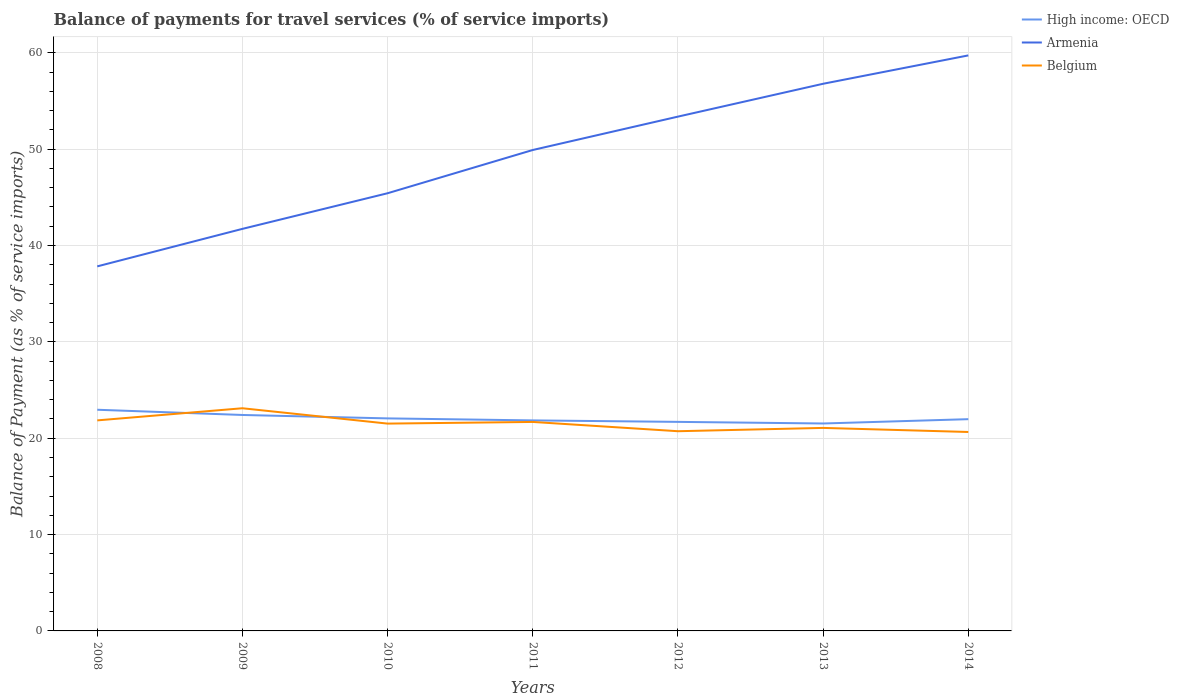Across all years, what is the maximum balance of payments for travel services in Belgium?
Make the answer very short. 20.65. In which year was the balance of payments for travel services in Belgium maximum?
Provide a short and direct response. 2014. What is the total balance of payments for travel services in High income: OECD in the graph?
Keep it short and to the point. 0.15. What is the difference between the highest and the second highest balance of payments for travel services in Belgium?
Give a very brief answer. 2.46. How many lines are there?
Your answer should be very brief. 3. What is the difference between two consecutive major ticks on the Y-axis?
Provide a succinct answer. 10. Does the graph contain any zero values?
Your answer should be very brief. No. Does the graph contain grids?
Keep it short and to the point. Yes. How are the legend labels stacked?
Give a very brief answer. Vertical. What is the title of the graph?
Give a very brief answer. Balance of payments for travel services (% of service imports). What is the label or title of the X-axis?
Offer a very short reply. Years. What is the label or title of the Y-axis?
Ensure brevity in your answer.  Balance of Payment (as % of service imports). What is the Balance of Payment (as % of service imports) of High income: OECD in 2008?
Your response must be concise. 22.96. What is the Balance of Payment (as % of service imports) in Armenia in 2008?
Your answer should be very brief. 37.84. What is the Balance of Payment (as % of service imports) in Belgium in 2008?
Your answer should be compact. 21.85. What is the Balance of Payment (as % of service imports) of High income: OECD in 2009?
Make the answer very short. 22.41. What is the Balance of Payment (as % of service imports) of Armenia in 2009?
Ensure brevity in your answer.  41.73. What is the Balance of Payment (as % of service imports) of Belgium in 2009?
Offer a terse response. 23.11. What is the Balance of Payment (as % of service imports) of High income: OECD in 2010?
Provide a succinct answer. 22.06. What is the Balance of Payment (as % of service imports) of Armenia in 2010?
Keep it short and to the point. 45.43. What is the Balance of Payment (as % of service imports) in Belgium in 2010?
Provide a short and direct response. 21.52. What is the Balance of Payment (as % of service imports) in High income: OECD in 2011?
Make the answer very short. 21.85. What is the Balance of Payment (as % of service imports) of Armenia in 2011?
Offer a very short reply. 49.91. What is the Balance of Payment (as % of service imports) of Belgium in 2011?
Give a very brief answer. 21.69. What is the Balance of Payment (as % of service imports) of High income: OECD in 2012?
Make the answer very short. 21.7. What is the Balance of Payment (as % of service imports) in Armenia in 2012?
Your response must be concise. 53.38. What is the Balance of Payment (as % of service imports) of Belgium in 2012?
Offer a terse response. 20.73. What is the Balance of Payment (as % of service imports) of High income: OECD in 2013?
Offer a very short reply. 21.53. What is the Balance of Payment (as % of service imports) in Armenia in 2013?
Ensure brevity in your answer.  56.79. What is the Balance of Payment (as % of service imports) in Belgium in 2013?
Offer a terse response. 21.07. What is the Balance of Payment (as % of service imports) in High income: OECD in 2014?
Your answer should be very brief. 21.98. What is the Balance of Payment (as % of service imports) of Armenia in 2014?
Provide a succinct answer. 59.73. What is the Balance of Payment (as % of service imports) of Belgium in 2014?
Provide a succinct answer. 20.65. Across all years, what is the maximum Balance of Payment (as % of service imports) of High income: OECD?
Ensure brevity in your answer.  22.96. Across all years, what is the maximum Balance of Payment (as % of service imports) of Armenia?
Provide a short and direct response. 59.73. Across all years, what is the maximum Balance of Payment (as % of service imports) in Belgium?
Keep it short and to the point. 23.11. Across all years, what is the minimum Balance of Payment (as % of service imports) of High income: OECD?
Ensure brevity in your answer.  21.53. Across all years, what is the minimum Balance of Payment (as % of service imports) of Armenia?
Offer a terse response. 37.84. Across all years, what is the minimum Balance of Payment (as % of service imports) of Belgium?
Make the answer very short. 20.65. What is the total Balance of Payment (as % of service imports) in High income: OECD in the graph?
Ensure brevity in your answer.  154.48. What is the total Balance of Payment (as % of service imports) in Armenia in the graph?
Your answer should be compact. 344.81. What is the total Balance of Payment (as % of service imports) in Belgium in the graph?
Give a very brief answer. 150.62. What is the difference between the Balance of Payment (as % of service imports) of High income: OECD in 2008 and that in 2009?
Give a very brief answer. 0.54. What is the difference between the Balance of Payment (as % of service imports) of Armenia in 2008 and that in 2009?
Make the answer very short. -3.89. What is the difference between the Balance of Payment (as % of service imports) of Belgium in 2008 and that in 2009?
Your response must be concise. -1.26. What is the difference between the Balance of Payment (as % of service imports) of High income: OECD in 2008 and that in 2010?
Your response must be concise. 0.9. What is the difference between the Balance of Payment (as % of service imports) in Armenia in 2008 and that in 2010?
Provide a short and direct response. -7.59. What is the difference between the Balance of Payment (as % of service imports) of Belgium in 2008 and that in 2010?
Offer a terse response. 0.33. What is the difference between the Balance of Payment (as % of service imports) of High income: OECD in 2008 and that in 2011?
Your response must be concise. 1.11. What is the difference between the Balance of Payment (as % of service imports) in Armenia in 2008 and that in 2011?
Offer a terse response. -12.08. What is the difference between the Balance of Payment (as % of service imports) in Belgium in 2008 and that in 2011?
Offer a terse response. 0.16. What is the difference between the Balance of Payment (as % of service imports) of High income: OECD in 2008 and that in 2012?
Your answer should be very brief. 1.26. What is the difference between the Balance of Payment (as % of service imports) of Armenia in 2008 and that in 2012?
Your answer should be compact. -15.54. What is the difference between the Balance of Payment (as % of service imports) in Belgium in 2008 and that in 2012?
Offer a very short reply. 1.12. What is the difference between the Balance of Payment (as % of service imports) of High income: OECD in 2008 and that in 2013?
Ensure brevity in your answer.  1.43. What is the difference between the Balance of Payment (as % of service imports) of Armenia in 2008 and that in 2013?
Keep it short and to the point. -18.95. What is the difference between the Balance of Payment (as % of service imports) in Belgium in 2008 and that in 2013?
Provide a short and direct response. 0.78. What is the difference between the Balance of Payment (as % of service imports) of High income: OECD in 2008 and that in 2014?
Provide a succinct answer. 0.98. What is the difference between the Balance of Payment (as % of service imports) in Armenia in 2008 and that in 2014?
Keep it short and to the point. -21.9. What is the difference between the Balance of Payment (as % of service imports) of Belgium in 2008 and that in 2014?
Your response must be concise. 1.2. What is the difference between the Balance of Payment (as % of service imports) in High income: OECD in 2009 and that in 2010?
Make the answer very short. 0.36. What is the difference between the Balance of Payment (as % of service imports) in Armenia in 2009 and that in 2010?
Your response must be concise. -3.7. What is the difference between the Balance of Payment (as % of service imports) in Belgium in 2009 and that in 2010?
Your answer should be very brief. 1.59. What is the difference between the Balance of Payment (as % of service imports) in High income: OECD in 2009 and that in 2011?
Give a very brief answer. 0.56. What is the difference between the Balance of Payment (as % of service imports) of Armenia in 2009 and that in 2011?
Keep it short and to the point. -8.19. What is the difference between the Balance of Payment (as % of service imports) of Belgium in 2009 and that in 2011?
Keep it short and to the point. 1.42. What is the difference between the Balance of Payment (as % of service imports) of High income: OECD in 2009 and that in 2012?
Offer a terse response. 0.72. What is the difference between the Balance of Payment (as % of service imports) in Armenia in 2009 and that in 2012?
Your response must be concise. -11.65. What is the difference between the Balance of Payment (as % of service imports) of Belgium in 2009 and that in 2012?
Your answer should be very brief. 2.38. What is the difference between the Balance of Payment (as % of service imports) in High income: OECD in 2009 and that in 2013?
Your answer should be very brief. 0.88. What is the difference between the Balance of Payment (as % of service imports) of Armenia in 2009 and that in 2013?
Ensure brevity in your answer.  -15.06. What is the difference between the Balance of Payment (as % of service imports) in Belgium in 2009 and that in 2013?
Ensure brevity in your answer.  2.04. What is the difference between the Balance of Payment (as % of service imports) of High income: OECD in 2009 and that in 2014?
Your answer should be very brief. 0.44. What is the difference between the Balance of Payment (as % of service imports) in Armenia in 2009 and that in 2014?
Give a very brief answer. -18. What is the difference between the Balance of Payment (as % of service imports) in Belgium in 2009 and that in 2014?
Keep it short and to the point. 2.46. What is the difference between the Balance of Payment (as % of service imports) in High income: OECD in 2010 and that in 2011?
Your answer should be compact. 0.21. What is the difference between the Balance of Payment (as % of service imports) in Armenia in 2010 and that in 2011?
Your answer should be compact. -4.49. What is the difference between the Balance of Payment (as % of service imports) in Belgium in 2010 and that in 2011?
Your answer should be compact. -0.17. What is the difference between the Balance of Payment (as % of service imports) in High income: OECD in 2010 and that in 2012?
Ensure brevity in your answer.  0.36. What is the difference between the Balance of Payment (as % of service imports) of Armenia in 2010 and that in 2012?
Your response must be concise. -7.95. What is the difference between the Balance of Payment (as % of service imports) in Belgium in 2010 and that in 2012?
Make the answer very short. 0.79. What is the difference between the Balance of Payment (as % of service imports) in High income: OECD in 2010 and that in 2013?
Provide a succinct answer. 0.53. What is the difference between the Balance of Payment (as % of service imports) of Armenia in 2010 and that in 2013?
Keep it short and to the point. -11.36. What is the difference between the Balance of Payment (as % of service imports) of Belgium in 2010 and that in 2013?
Provide a short and direct response. 0.45. What is the difference between the Balance of Payment (as % of service imports) in High income: OECD in 2010 and that in 2014?
Provide a short and direct response. 0.08. What is the difference between the Balance of Payment (as % of service imports) of Armenia in 2010 and that in 2014?
Provide a succinct answer. -14.31. What is the difference between the Balance of Payment (as % of service imports) in Belgium in 2010 and that in 2014?
Provide a short and direct response. 0.87. What is the difference between the Balance of Payment (as % of service imports) of High income: OECD in 2011 and that in 2012?
Give a very brief answer. 0.15. What is the difference between the Balance of Payment (as % of service imports) of Armenia in 2011 and that in 2012?
Make the answer very short. -3.46. What is the difference between the Balance of Payment (as % of service imports) in Belgium in 2011 and that in 2012?
Ensure brevity in your answer.  0.96. What is the difference between the Balance of Payment (as % of service imports) in High income: OECD in 2011 and that in 2013?
Your response must be concise. 0.32. What is the difference between the Balance of Payment (as % of service imports) in Armenia in 2011 and that in 2013?
Your answer should be very brief. -6.87. What is the difference between the Balance of Payment (as % of service imports) of Belgium in 2011 and that in 2013?
Provide a succinct answer. 0.62. What is the difference between the Balance of Payment (as % of service imports) of High income: OECD in 2011 and that in 2014?
Your response must be concise. -0.13. What is the difference between the Balance of Payment (as % of service imports) in Armenia in 2011 and that in 2014?
Your answer should be compact. -9.82. What is the difference between the Balance of Payment (as % of service imports) of Belgium in 2011 and that in 2014?
Give a very brief answer. 1.04. What is the difference between the Balance of Payment (as % of service imports) in High income: OECD in 2012 and that in 2013?
Your answer should be very brief. 0.17. What is the difference between the Balance of Payment (as % of service imports) in Armenia in 2012 and that in 2013?
Provide a succinct answer. -3.41. What is the difference between the Balance of Payment (as % of service imports) in Belgium in 2012 and that in 2013?
Provide a succinct answer. -0.34. What is the difference between the Balance of Payment (as % of service imports) in High income: OECD in 2012 and that in 2014?
Provide a short and direct response. -0.28. What is the difference between the Balance of Payment (as % of service imports) in Armenia in 2012 and that in 2014?
Offer a terse response. -6.35. What is the difference between the Balance of Payment (as % of service imports) of Belgium in 2012 and that in 2014?
Offer a terse response. 0.08. What is the difference between the Balance of Payment (as % of service imports) of High income: OECD in 2013 and that in 2014?
Offer a terse response. -0.45. What is the difference between the Balance of Payment (as % of service imports) in Armenia in 2013 and that in 2014?
Provide a short and direct response. -2.94. What is the difference between the Balance of Payment (as % of service imports) in Belgium in 2013 and that in 2014?
Give a very brief answer. 0.42. What is the difference between the Balance of Payment (as % of service imports) of High income: OECD in 2008 and the Balance of Payment (as % of service imports) of Armenia in 2009?
Keep it short and to the point. -18.77. What is the difference between the Balance of Payment (as % of service imports) in High income: OECD in 2008 and the Balance of Payment (as % of service imports) in Belgium in 2009?
Make the answer very short. -0.15. What is the difference between the Balance of Payment (as % of service imports) of Armenia in 2008 and the Balance of Payment (as % of service imports) of Belgium in 2009?
Provide a short and direct response. 14.73. What is the difference between the Balance of Payment (as % of service imports) of High income: OECD in 2008 and the Balance of Payment (as % of service imports) of Armenia in 2010?
Offer a very short reply. -22.47. What is the difference between the Balance of Payment (as % of service imports) of High income: OECD in 2008 and the Balance of Payment (as % of service imports) of Belgium in 2010?
Your answer should be compact. 1.44. What is the difference between the Balance of Payment (as % of service imports) in Armenia in 2008 and the Balance of Payment (as % of service imports) in Belgium in 2010?
Keep it short and to the point. 16.32. What is the difference between the Balance of Payment (as % of service imports) in High income: OECD in 2008 and the Balance of Payment (as % of service imports) in Armenia in 2011?
Ensure brevity in your answer.  -26.96. What is the difference between the Balance of Payment (as % of service imports) in High income: OECD in 2008 and the Balance of Payment (as % of service imports) in Belgium in 2011?
Provide a short and direct response. 1.26. What is the difference between the Balance of Payment (as % of service imports) in Armenia in 2008 and the Balance of Payment (as % of service imports) in Belgium in 2011?
Your response must be concise. 16.15. What is the difference between the Balance of Payment (as % of service imports) of High income: OECD in 2008 and the Balance of Payment (as % of service imports) of Armenia in 2012?
Provide a succinct answer. -30.42. What is the difference between the Balance of Payment (as % of service imports) in High income: OECD in 2008 and the Balance of Payment (as % of service imports) in Belgium in 2012?
Your answer should be very brief. 2.23. What is the difference between the Balance of Payment (as % of service imports) of Armenia in 2008 and the Balance of Payment (as % of service imports) of Belgium in 2012?
Your response must be concise. 17.11. What is the difference between the Balance of Payment (as % of service imports) in High income: OECD in 2008 and the Balance of Payment (as % of service imports) in Armenia in 2013?
Your answer should be compact. -33.83. What is the difference between the Balance of Payment (as % of service imports) in High income: OECD in 2008 and the Balance of Payment (as % of service imports) in Belgium in 2013?
Your response must be concise. 1.89. What is the difference between the Balance of Payment (as % of service imports) in Armenia in 2008 and the Balance of Payment (as % of service imports) in Belgium in 2013?
Provide a succinct answer. 16.77. What is the difference between the Balance of Payment (as % of service imports) in High income: OECD in 2008 and the Balance of Payment (as % of service imports) in Armenia in 2014?
Your answer should be compact. -36.78. What is the difference between the Balance of Payment (as % of service imports) of High income: OECD in 2008 and the Balance of Payment (as % of service imports) of Belgium in 2014?
Give a very brief answer. 2.31. What is the difference between the Balance of Payment (as % of service imports) in Armenia in 2008 and the Balance of Payment (as % of service imports) in Belgium in 2014?
Offer a very short reply. 17.19. What is the difference between the Balance of Payment (as % of service imports) in High income: OECD in 2009 and the Balance of Payment (as % of service imports) in Armenia in 2010?
Your answer should be very brief. -23.01. What is the difference between the Balance of Payment (as % of service imports) in High income: OECD in 2009 and the Balance of Payment (as % of service imports) in Belgium in 2010?
Your answer should be very brief. 0.9. What is the difference between the Balance of Payment (as % of service imports) in Armenia in 2009 and the Balance of Payment (as % of service imports) in Belgium in 2010?
Ensure brevity in your answer.  20.21. What is the difference between the Balance of Payment (as % of service imports) of High income: OECD in 2009 and the Balance of Payment (as % of service imports) of Armenia in 2011?
Provide a short and direct response. -27.5. What is the difference between the Balance of Payment (as % of service imports) in High income: OECD in 2009 and the Balance of Payment (as % of service imports) in Belgium in 2011?
Give a very brief answer. 0.72. What is the difference between the Balance of Payment (as % of service imports) in Armenia in 2009 and the Balance of Payment (as % of service imports) in Belgium in 2011?
Provide a short and direct response. 20.04. What is the difference between the Balance of Payment (as % of service imports) in High income: OECD in 2009 and the Balance of Payment (as % of service imports) in Armenia in 2012?
Provide a succinct answer. -30.97. What is the difference between the Balance of Payment (as % of service imports) in High income: OECD in 2009 and the Balance of Payment (as % of service imports) in Belgium in 2012?
Your answer should be very brief. 1.69. What is the difference between the Balance of Payment (as % of service imports) of Armenia in 2009 and the Balance of Payment (as % of service imports) of Belgium in 2012?
Provide a short and direct response. 21. What is the difference between the Balance of Payment (as % of service imports) in High income: OECD in 2009 and the Balance of Payment (as % of service imports) in Armenia in 2013?
Your response must be concise. -34.38. What is the difference between the Balance of Payment (as % of service imports) in High income: OECD in 2009 and the Balance of Payment (as % of service imports) in Belgium in 2013?
Provide a succinct answer. 1.34. What is the difference between the Balance of Payment (as % of service imports) in Armenia in 2009 and the Balance of Payment (as % of service imports) in Belgium in 2013?
Provide a short and direct response. 20.66. What is the difference between the Balance of Payment (as % of service imports) in High income: OECD in 2009 and the Balance of Payment (as % of service imports) in Armenia in 2014?
Your answer should be compact. -37.32. What is the difference between the Balance of Payment (as % of service imports) of High income: OECD in 2009 and the Balance of Payment (as % of service imports) of Belgium in 2014?
Your answer should be compact. 1.77. What is the difference between the Balance of Payment (as % of service imports) in Armenia in 2009 and the Balance of Payment (as % of service imports) in Belgium in 2014?
Offer a very short reply. 21.08. What is the difference between the Balance of Payment (as % of service imports) of High income: OECD in 2010 and the Balance of Payment (as % of service imports) of Armenia in 2011?
Make the answer very short. -27.86. What is the difference between the Balance of Payment (as % of service imports) of High income: OECD in 2010 and the Balance of Payment (as % of service imports) of Belgium in 2011?
Give a very brief answer. 0.37. What is the difference between the Balance of Payment (as % of service imports) in Armenia in 2010 and the Balance of Payment (as % of service imports) in Belgium in 2011?
Keep it short and to the point. 23.74. What is the difference between the Balance of Payment (as % of service imports) in High income: OECD in 2010 and the Balance of Payment (as % of service imports) in Armenia in 2012?
Your answer should be compact. -31.32. What is the difference between the Balance of Payment (as % of service imports) in High income: OECD in 2010 and the Balance of Payment (as % of service imports) in Belgium in 2012?
Your answer should be compact. 1.33. What is the difference between the Balance of Payment (as % of service imports) in Armenia in 2010 and the Balance of Payment (as % of service imports) in Belgium in 2012?
Provide a short and direct response. 24.7. What is the difference between the Balance of Payment (as % of service imports) of High income: OECD in 2010 and the Balance of Payment (as % of service imports) of Armenia in 2013?
Provide a short and direct response. -34.73. What is the difference between the Balance of Payment (as % of service imports) in High income: OECD in 2010 and the Balance of Payment (as % of service imports) in Belgium in 2013?
Offer a terse response. 0.99. What is the difference between the Balance of Payment (as % of service imports) in Armenia in 2010 and the Balance of Payment (as % of service imports) in Belgium in 2013?
Provide a short and direct response. 24.36. What is the difference between the Balance of Payment (as % of service imports) in High income: OECD in 2010 and the Balance of Payment (as % of service imports) in Armenia in 2014?
Your answer should be very brief. -37.67. What is the difference between the Balance of Payment (as % of service imports) of High income: OECD in 2010 and the Balance of Payment (as % of service imports) of Belgium in 2014?
Your response must be concise. 1.41. What is the difference between the Balance of Payment (as % of service imports) of Armenia in 2010 and the Balance of Payment (as % of service imports) of Belgium in 2014?
Offer a terse response. 24.78. What is the difference between the Balance of Payment (as % of service imports) in High income: OECD in 2011 and the Balance of Payment (as % of service imports) in Armenia in 2012?
Keep it short and to the point. -31.53. What is the difference between the Balance of Payment (as % of service imports) in High income: OECD in 2011 and the Balance of Payment (as % of service imports) in Belgium in 2012?
Provide a short and direct response. 1.12. What is the difference between the Balance of Payment (as % of service imports) in Armenia in 2011 and the Balance of Payment (as % of service imports) in Belgium in 2012?
Make the answer very short. 29.19. What is the difference between the Balance of Payment (as % of service imports) of High income: OECD in 2011 and the Balance of Payment (as % of service imports) of Armenia in 2013?
Offer a very short reply. -34.94. What is the difference between the Balance of Payment (as % of service imports) of High income: OECD in 2011 and the Balance of Payment (as % of service imports) of Belgium in 2013?
Your answer should be very brief. 0.78. What is the difference between the Balance of Payment (as % of service imports) in Armenia in 2011 and the Balance of Payment (as % of service imports) in Belgium in 2013?
Your response must be concise. 28.84. What is the difference between the Balance of Payment (as % of service imports) in High income: OECD in 2011 and the Balance of Payment (as % of service imports) in Armenia in 2014?
Keep it short and to the point. -37.88. What is the difference between the Balance of Payment (as % of service imports) of High income: OECD in 2011 and the Balance of Payment (as % of service imports) of Belgium in 2014?
Offer a terse response. 1.2. What is the difference between the Balance of Payment (as % of service imports) in Armenia in 2011 and the Balance of Payment (as % of service imports) in Belgium in 2014?
Offer a very short reply. 29.27. What is the difference between the Balance of Payment (as % of service imports) in High income: OECD in 2012 and the Balance of Payment (as % of service imports) in Armenia in 2013?
Offer a very short reply. -35.09. What is the difference between the Balance of Payment (as % of service imports) of High income: OECD in 2012 and the Balance of Payment (as % of service imports) of Belgium in 2013?
Your answer should be compact. 0.63. What is the difference between the Balance of Payment (as % of service imports) of Armenia in 2012 and the Balance of Payment (as % of service imports) of Belgium in 2013?
Provide a succinct answer. 32.31. What is the difference between the Balance of Payment (as % of service imports) of High income: OECD in 2012 and the Balance of Payment (as % of service imports) of Armenia in 2014?
Offer a very short reply. -38.04. What is the difference between the Balance of Payment (as % of service imports) of High income: OECD in 2012 and the Balance of Payment (as % of service imports) of Belgium in 2014?
Your answer should be very brief. 1.05. What is the difference between the Balance of Payment (as % of service imports) of Armenia in 2012 and the Balance of Payment (as % of service imports) of Belgium in 2014?
Make the answer very short. 32.73. What is the difference between the Balance of Payment (as % of service imports) of High income: OECD in 2013 and the Balance of Payment (as % of service imports) of Armenia in 2014?
Provide a succinct answer. -38.2. What is the difference between the Balance of Payment (as % of service imports) of High income: OECD in 2013 and the Balance of Payment (as % of service imports) of Belgium in 2014?
Make the answer very short. 0.88. What is the difference between the Balance of Payment (as % of service imports) in Armenia in 2013 and the Balance of Payment (as % of service imports) in Belgium in 2014?
Offer a very short reply. 36.14. What is the average Balance of Payment (as % of service imports) in High income: OECD per year?
Keep it short and to the point. 22.07. What is the average Balance of Payment (as % of service imports) of Armenia per year?
Your answer should be very brief. 49.26. What is the average Balance of Payment (as % of service imports) in Belgium per year?
Make the answer very short. 21.52. In the year 2008, what is the difference between the Balance of Payment (as % of service imports) of High income: OECD and Balance of Payment (as % of service imports) of Armenia?
Your answer should be compact. -14.88. In the year 2008, what is the difference between the Balance of Payment (as % of service imports) in High income: OECD and Balance of Payment (as % of service imports) in Belgium?
Make the answer very short. 1.1. In the year 2008, what is the difference between the Balance of Payment (as % of service imports) of Armenia and Balance of Payment (as % of service imports) of Belgium?
Keep it short and to the point. 15.99. In the year 2009, what is the difference between the Balance of Payment (as % of service imports) in High income: OECD and Balance of Payment (as % of service imports) in Armenia?
Your response must be concise. -19.32. In the year 2009, what is the difference between the Balance of Payment (as % of service imports) in High income: OECD and Balance of Payment (as % of service imports) in Belgium?
Provide a succinct answer. -0.7. In the year 2009, what is the difference between the Balance of Payment (as % of service imports) of Armenia and Balance of Payment (as % of service imports) of Belgium?
Offer a terse response. 18.62. In the year 2010, what is the difference between the Balance of Payment (as % of service imports) in High income: OECD and Balance of Payment (as % of service imports) in Armenia?
Make the answer very short. -23.37. In the year 2010, what is the difference between the Balance of Payment (as % of service imports) in High income: OECD and Balance of Payment (as % of service imports) in Belgium?
Provide a short and direct response. 0.54. In the year 2010, what is the difference between the Balance of Payment (as % of service imports) of Armenia and Balance of Payment (as % of service imports) of Belgium?
Your answer should be compact. 23.91. In the year 2011, what is the difference between the Balance of Payment (as % of service imports) of High income: OECD and Balance of Payment (as % of service imports) of Armenia?
Keep it short and to the point. -28.07. In the year 2011, what is the difference between the Balance of Payment (as % of service imports) of High income: OECD and Balance of Payment (as % of service imports) of Belgium?
Provide a succinct answer. 0.16. In the year 2011, what is the difference between the Balance of Payment (as % of service imports) in Armenia and Balance of Payment (as % of service imports) in Belgium?
Ensure brevity in your answer.  28.22. In the year 2012, what is the difference between the Balance of Payment (as % of service imports) of High income: OECD and Balance of Payment (as % of service imports) of Armenia?
Ensure brevity in your answer.  -31.68. In the year 2012, what is the difference between the Balance of Payment (as % of service imports) of High income: OECD and Balance of Payment (as % of service imports) of Belgium?
Provide a succinct answer. 0.97. In the year 2012, what is the difference between the Balance of Payment (as % of service imports) in Armenia and Balance of Payment (as % of service imports) in Belgium?
Provide a short and direct response. 32.65. In the year 2013, what is the difference between the Balance of Payment (as % of service imports) of High income: OECD and Balance of Payment (as % of service imports) of Armenia?
Provide a succinct answer. -35.26. In the year 2013, what is the difference between the Balance of Payment (as % of service imports) of High income: OECD and Balance of Payment (as % of service imports) of Belgium?
Offer a terse response. 0.46. In the year 2013, what is the difference between the Balance of Payment (as % of service imports) of Armenia and Balance of Payment (as % of service imports) of Belgium?
Keep it short and to the point. 35.72. In the year 2014, what is the difference between the Balance of Payment (as % of service imports) of High income: OECD and Balance of Payment (as % of service imports) of Armenia?
Provide a succinct answer. -37.75. In the year 2014, what is the difference between the Balance of Payment (as % of service imports) in High income: OECD and Balance of Payment (as % of service imports) in Belgium?
Keep it short and to the point. 1.33. In the year 2014, what is the difference between the Balance of Payment (as % of service imports) of Armenia and Balance of Payment (as % of service imports) of Belgium?
Your answer should be compact. 39.08. What is the ratio of the Balance of Payment (as % of service imports) of High income: OECD in 2008 to that in 2009?
Your answer should be compact. 1.02. What is the ratio of the Balance of Payment (as % of service imports) of Armenia in 2008 to that in 2009?
Provide a short and direct response. 0.91. What is the ratio of the Balance of Payment (as % of service imports) in Belgium in 2008 to that in 2009?
Provide a succinct answer. 0.95. What is the ratio of the Balance of Payment (as % of service imports) in High income: OECD in 2008 to that in 2010?
Ensure brevity in your answer.  1.04. What is the ratio of the Balance of Payment (as % of service imports) in Armenia in 2008 to that in 2010?
Make the answer very short. 0.83. What is the ratio of the Balance of Payment (as % of service imports) of Belgium in 2008 to that in 2010?
Your answer should be very brief. 1.02. What is the ratio of the Balance of Payment (as % of service imports) in High income: OECD in 2008 to that in 2011?
Offer a terse response. 1.05. What is the ratio of the Balance of Payment (as % of service imports) of Armenia in 2008 to that in 2011?
Keep it short and to the point. 0.76. What is the ratio of the Balance of Payment (as % of service imports) in Belgium in 2008 to that in 2011?
Offer a very short reply. 1.01. What is the ratio of the Balance of Payment (as % of service imports) in High income: OECD in 2008 to that in 2012?
Ensure brevity in your answer.  1.06. What is the ratio of the Balance of Payment (as % of service imports) in Armenia in 2008 to that in 2012?
Your response must be concise. 0.71. What is the ratio of the Balance of Payment (as % of service imports) of Belgium in 2008 to that in 2012?
Offer a terse response. 1.05. What is the ratio of the Balance of Payment (as % of service imports) in High income: OECD in 2008 to that in 2013?
Offer a very short reply. 1.07. What is the ratio of the Balance of Payment (as % of service imports) of Armenia in 2008 to that in 2013?
Provide a short and direct response. 0.67. What is the ratio of the Balance of Payment (as % of service imports) of Belgium in 2008 to that in 2013?
Provide a short and direct response. 1.04. What is the ratio of the Balance of Payment (as % of service imports) in High income: OECD in 2008 to that in 2014?
Ensure brevity in your answer.  1.04. What is the ratio of the Balance of Payment (as % of service imports) in Armenia in 2008 to that in 2014?
Your answer should be very brief. 0.63. What is the ratio of the Balance of Payment (as % of service imports) of Belgium in 2008 to that in 2014?
Keep it short and to the point. 1.06. What is the ratio of the Balance of Payment (as % of service imports) of High income: OECD in 2009 to that in 2010?
Offer a very short reply. 1.02. What is the ratio of the Balance of Payment (as % of service imports) of Armenia in 2009 to that in 2010?
Keep it short and to the point. 0.92. What is the ratio of the Balance of Payment (as % of service imports) of Belgium in 2009 to that in 2010?
Your answer should be very brief. 1.07. What is the ratio of the Balance of Payment (as % of service imports) in High income: OECD in 2009 to that in 2011?
Give a very brief answer. 1.03. What is the ratio of the Balance of Payment (as % of service imports) in Armenia in 2009 to that in 2011?
Your answer should be compact. 0.84. What is the ratio of the Balance of Payment (as % of service imports) of Belgium in 2009 to that in 2011?
Your answer should be compact. 1.07. What is the ratio of the Balance of Payment (as % of service imports) in High income: OECD in 2009 to that in 2012?
Provide a succinct answer. 1.03. What is the ratio of the Balance of Payment (as % of service imports) of Armenia in 2009 to that in 2012?
Provide a short and direct response. 0.78. What is the ratio of the Balance of Payment (as % of service imports) in Belgium in 2009 to that in 2012?
Provide a succinct answer. 1.11. What is the ratio of the Balance of Payment (as % of service imports) of High income: OECD in 2009 to that in 2013?
Keep it short and to the point. 1.04. What is the ratio of the Balance of Payment (as % of service imports) in Armenia in 2009 to that in 2013?
Offer a terse response. 0.73. What is the ratio of the Balance of Payment (as % of service imports) of Belgium in 2009 to that in 2013?
Your answer should be compact. 1.1. What is the ratio of the Balance of Payment (as % of service imports) of High income: OECD in 2009 to that in 2014?
Offer a terse response. 1.02. What is the ratio of the Balance of Payment (as % of service imports) of Armenia in 2009 to that in 2014?
Offer a terse response. 0.7. What is the ratio of the Balance of Payment (as % of service imports) of Belgium in 2009 to that in 2014?
Give a very brief answer. 1.12. What is the ratio of the Balance of Payment (as % of service imports) of High income: OECD in 2010 to that in 2011?
Offer a very short reply. 1.01. What is the ratio of the Balance of Payment (as % of service imports) of Armenia in 2010 to that in 2011?
Your answer should be very brief. 0.91. What is the ratio of the Balance of Payment (as % of service imports) in Belgium in 2010 to that in 2011?
Your answer should be compact. 0.99. What is the ratio of the Balance of Payment (as % of service imports) in High income: OECD in 2010 to that in 2012?
Your response must be concise. 1.02. What is the ratio of the Balance of Payment (as % of service imports) of Armenia in 2010 to that in 2012?
Provide a succinct answer. 0.85. What is the ratio of the Balance of Payment (as % of service imports) in Belgium in 2010 to that in 2012?
Ensure brevity in your answer.  1.04. What is the ratio of the Balance of Payment (as % of service imports) of High income: OECD in 2010 to that in 2013?
Make the answer very short. 1.02. What is the ratio of the Balance of Payment (as % of service imports) in Armenia in 2010 to that in 2013?
Provide a short and direct response. 0.8. What is the ratio of the Balance of Payment (as % of service imports) in Belgium in 2010 to that in 2013?
Make the answer very short. 1.02. What is the ratio of the Balance of Payment (as % of service imports) in High income: OECD in 2010 to that in 2014?
Offer a very short reply. 1. What is the ratio of the Balance of Payment (as % of service imports) in Armenia in 2010 to that in 2014?
Provide a short and direct response. 0.76. What is the ratio of the Balance of Payment (as % of service imports) of Belgium in 2010 to that in 2014?
Offer a very short reply. 1.04. What is the ratio of the Balance of Payment (as % of service imports) of Armenia in 2011 to that in 2012?
Offer a very short reply. 0.94. What is the ratio of the Balance of Payment (as % of service imports) in Belgium in 2011 to that in 2012?
Offer a terse response. 1.05. What is the ratio of the Balance of Payment (as % of service imports) in High income: OECD in 2011 to that in 2013?
Offer a very short reply. 1.01. What is the ratio of the Balance of Payment (as % of service imports) of Armenia in 2011 to that in 2013?
Offer a very short reply. 0.88. What is the ratio of the Balance of Payment (as % of service imports) in Belgium in 2011 to that in 2013?
Ensure brevity in your answer.  1.03. What is the ratio of the Balance of Payment (as % of service imports) of High income: OECD in 2011 to that in 2014?
Keep it short and to the point. 0.99. What is the ratio of the Balance of Payment (as % of service imports) of Armenia in 2011 to that in 2014?
Your answer should be very brief. 0.84. What is the ratio of the Balance of Payment (as % of service imports) in Belgium in 2011 to that in 2014?
Offer a very short reply. 1.05. What is the ratio of the Balance of Payment (as % of service imports) of High income: OECD in 2012 to that in 2013?
Keep it short and to the point. 1.01. What is the ratio of the Balance of Payment (as % of service imports) of Armenia in 2012 to that in 2013?
Your answer should be compact. 0.94. What is the ratio of the Balance of Payment (as % of service imports) of Belgium in 2012 to that in 2013?
Provide a short and direct response. 0.98. What is the ratio of the Balance of Payment (as % of service imports) of High income: OECD in 2012 to that in 2014?
Make the answer very short. 0.99. What is the ratio of the Balance of Payment (as % of service imports) in Armenia in 2012 to that in 2014?
Give a very brief answer. 0.89. What is the ratio of the Balance of Payment (as % of service imports) of Belgium in 2012 to that in 2014?
Provide a short and direct response. 1. What is the ratio of the Balance of Payment (as % of service imports) in High income: OECD in 2013 to that in 2014?
Ensure brevity in your answer.  0.98. What is the ratio of the Balance of Payment (as % of service imports) of Armenia in 2013 to that in 2014?
Your answer should be compact. 0.95. What is the ratio of the Balance of Payment (as % of service imports) of Belgium in 2013 to that in 2014?
Your answer should be compact. 1.02. What is the difference between the highest and the second highest Balance of Payment (as % of service imports) in High income: OECD?
Your answer should be very brief. 0.54. What is the difference between the highest and the second highest Balance of Payment (as % of service imports) in Armenia?
Offer a terse response. 2.94. What is the difference between the highest and the second highest Balance of Payment (as % of service imports) in Belgium?
Offer a terse response. 1.26. What is the difference between the highest and the lowest Balance of Payment (as % of service imports) in High income: OECD?
Ensure brevity in your answer.  1.43. What is the difference between the highest and the lowest Balance of Payment (as % of service imports) of Armenia?
Provide a succinct answer. 21.9. What is the difference between the highest and the lowest Balance of Payment (as % of service imports) in Belgium?
Keep it short and to the point. 2.46. 